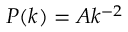<formula> <loc_0><loc_0><loc_500><loc_500>P ( k ) = A k ^ { - 2 }</formula> 